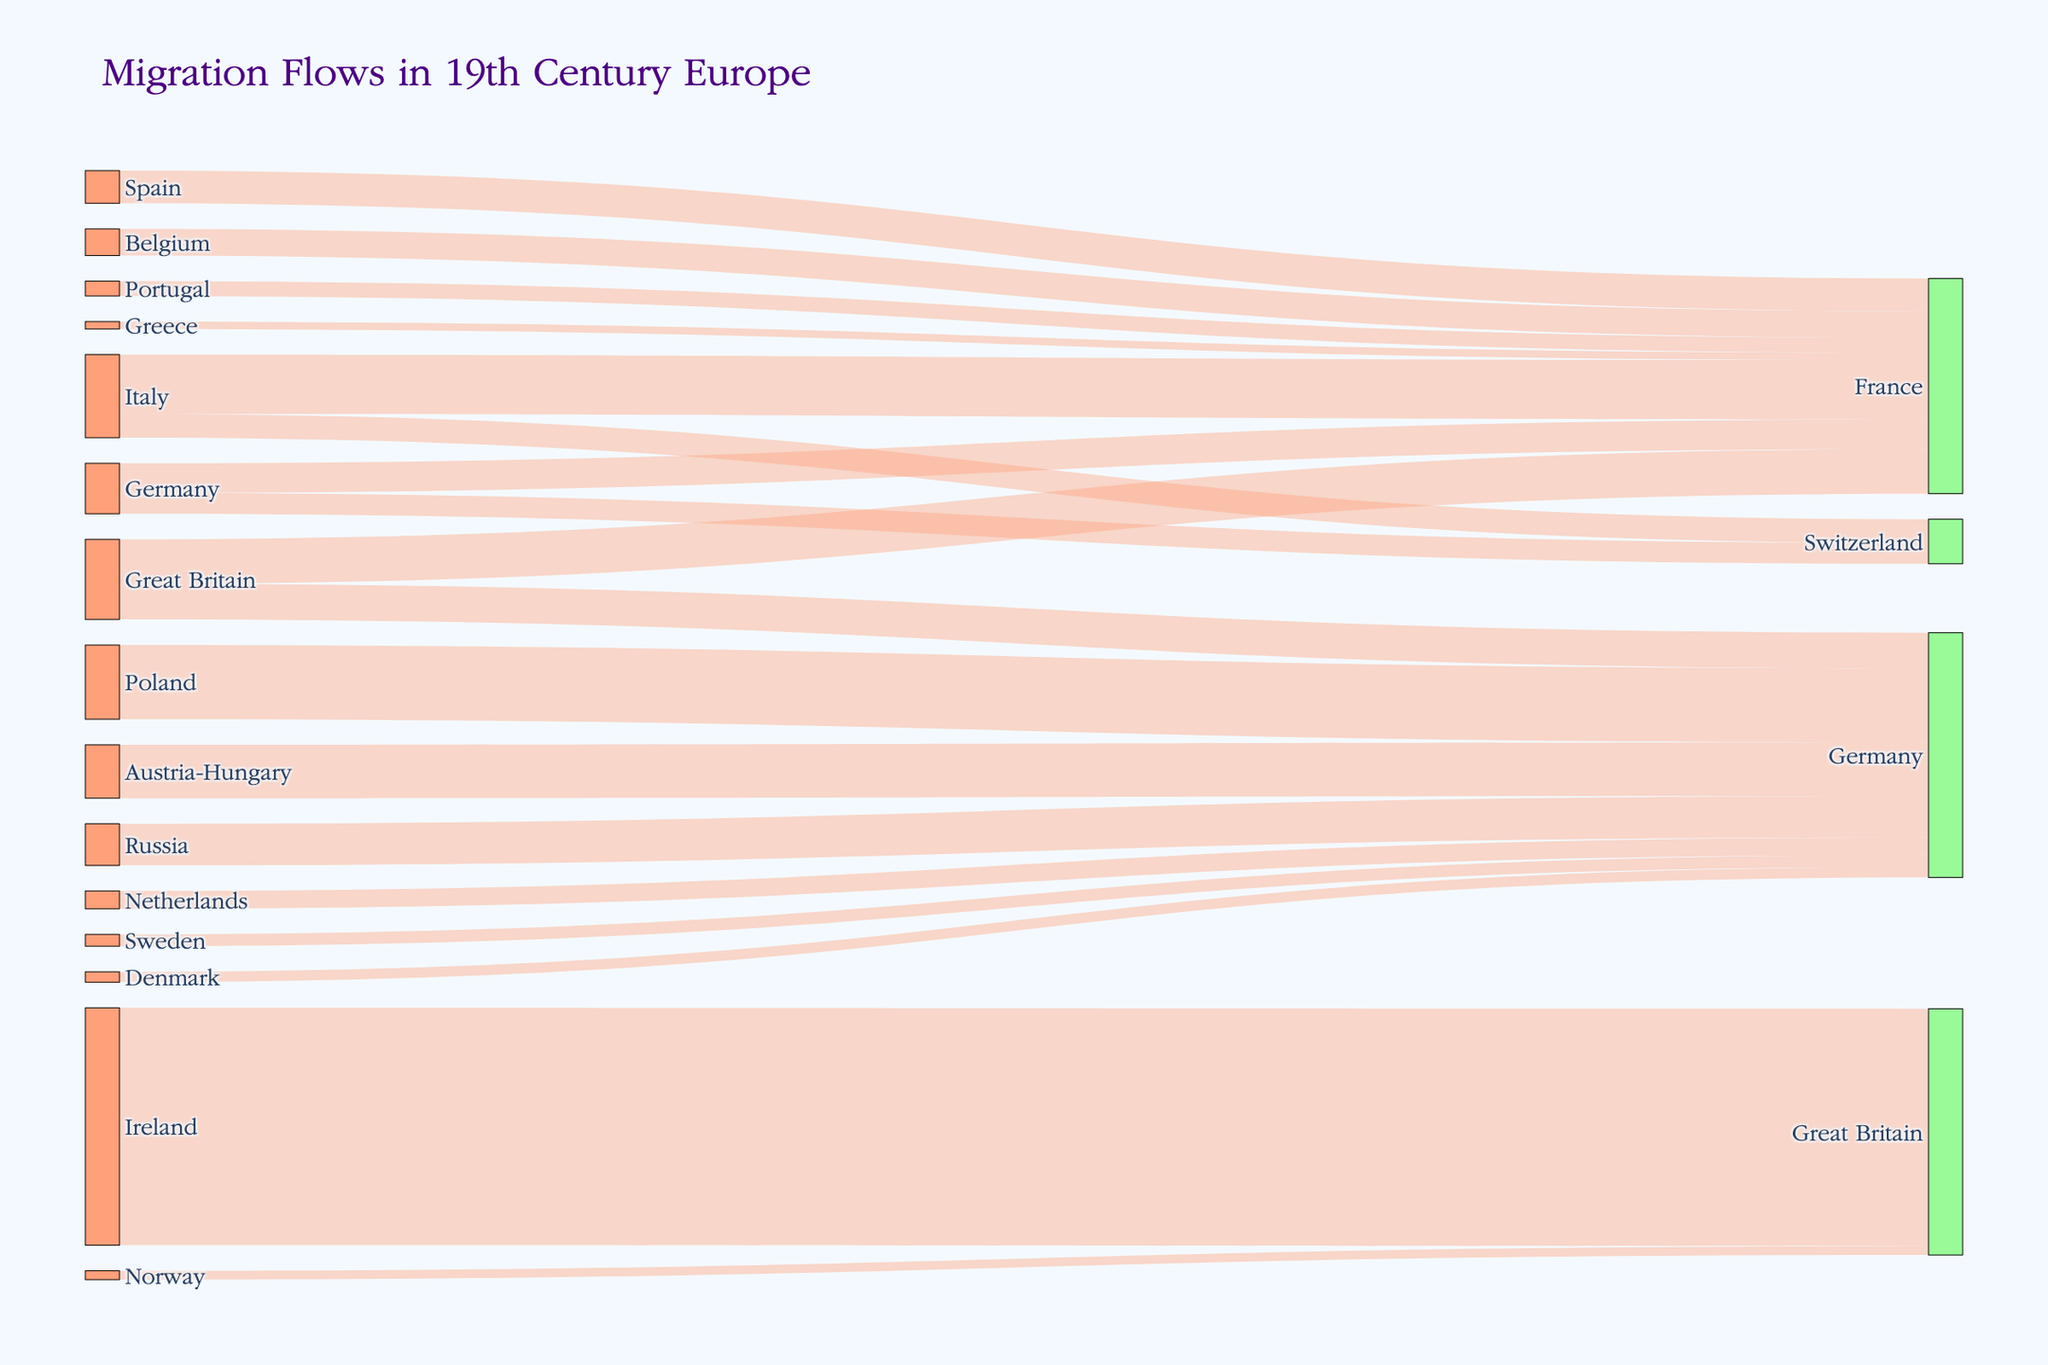Which country had the highest migration to Great Britain during the 19th century? By examining the Sankey diagram, observe the flows directed towards Great Britain. Ireland's flow to Great Britain is 800,000, which is the largest.
Answer: Ireland What is the total migration flow into Germany? Sum up all the migration values that end in Germany: 120,000 (Great Britain) + 250,000 (Poland) + 180,000 (Austria-Hungary) + 140,000 (Russia) + 60,000 (Netherlands) + 40,000 (Sweden) + 35,000 (Denmark) = 825,000.
Answer: 825,000 Which countries did Germany have migration flows to, and what are the respective values? Look at the flows starting from Germany and find the targets: 100,000 to France and 70,000 to Switzerland.
Answer: France: 100,000, Switzerland: 70,000 What is the average value of migrants flowing from Italy? Add the migration values from Italy and divide by the number of flows: (200,000 + 80,000) / 2 = 140,000.
Answer: 140,000 Compare the migration flows from Ireland and Italy. Which country had a higher overall migration flow? Sum up the migration values for each country: Ireland to Great Britain is 800,000; Italy to France is 200,000 and Italy to Switzerland is 80,000, totaling 280,000. Therefore, Ireland's flow is higher.
Answer: Ireland How many unique target countries are there in the Sankey diagram? Count the distinct target countries in the data: France, Germany, Switzerland, Great Britain. There are 4 unique target countries.
Answer: 4 What is the flow value from Great Britain to France? Identify the specific flow between Great Britain and France. The value is listed as 150,000.
Answer: 150,000 Which source country contributed the least to migration according to the diagram? Compare the lowest values associated with each source country. The smallest individual flow is from Greece to France, with 25,000 migrants.
Answer: Greece What is the combined flow from Italy and Spain to France? Add the migration values from both Italy and Spain to France: 200,000 (Italy) + 110,000 (Spain) = 310,000.
Answer: 310,000 From which country did Norway have migration flows, and what was the value? Check for Norway in the sources and identify its flow: Norway to Great Britain is 30,000.
Answer: Great Britain: 30,000 